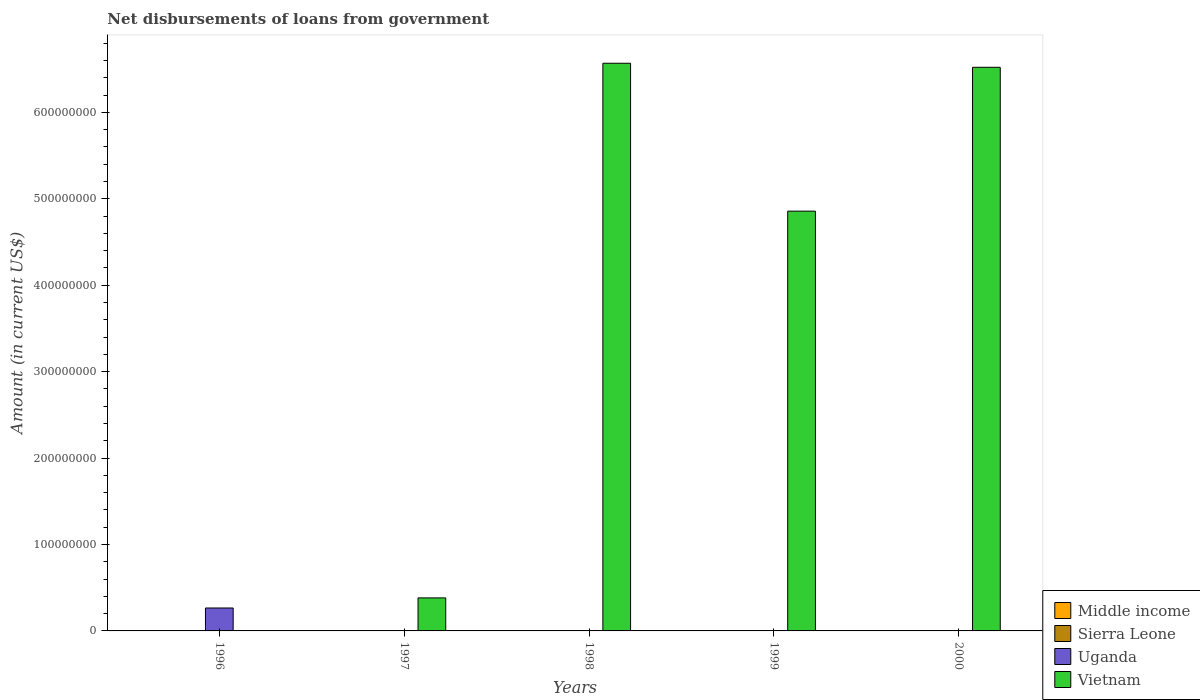How many bars are there on the 5th tick from the left?
Your answer should be compact. 2. How many bars are there on the 5th tick from the right?
Provide a succinct answer. 1. What is the label of the 4th group of bars from the left?
Ensure brevity in your answer.  1999. In how many cases, is the number of bars for a given year not equal to the number of legend labels?
Offer a terse response. 5. Across all years, what is the maximum amount of loan disbursed from government in Uganda?
Your response must be concise. 2.65e+07. Across all years, what is the minimum amount of loan disbursed from government in Uganda?
Your answer should be compact. 0. What is the total amount of loan disbursed from government in Sierra Leone in the graph?
Your answer should be compact. 6.80e+04. What is the difference between the amount of loan disbursed from government in Vietnam in 1998 and that in 2000?
Your answer should be very brief. 4.68e+06. What is the average amount of loan disbursed from government in Sierra Leone per year?
Your answer should be compact. 1.36e+04. What is the difference between the highest and the second highest amount of loan disbursed from government in Vietnam?
Provide a succinct answer. 4.68e+06. What is the difference between the highest and the lowest amount of loan disbursed from government in Uganda?
Your response must be concise. 2.65e+07. Is it the case that in every year, the sum of the amount of loan disbursed from government in Vietnam and amount of loan disbursed from government in Sierra Leone is greater than the sum of amount of loan disbursed from government in Uganda and amount of loan disbursed from government in Middle income?
Make the answer very short. No. Does the graph contain any zero values?
Provide a succinct answer. Yes. Does the graph contain grids?
Offer a terse response. No. What is the title of the graph?
Your answer should be compact. Net disbursements of loans from government. Does "Middle income" appear as one of the legend labels in the graph?
Give a very brief answer. Yes. What is the Amount (in current US$) in Middle income in 1996?
Make the answer very short. 0. What is the Amount (in current US$) in Sierra Leone in 1996?
Make the answer very short. 0. What is the Amount (in current US$) of Uganda in 1996?
Provide a succinct answer. 2.65e+07. What is the Amount (in current US$) in Vietnam in 1996?
Provide a succinct answer. 0. What is the Amount (in current US$) in Middle income in 1997?
Your answer should be compact. 0. What is the Amount (in current US$) of Sierra Leone in 1997?
Keep it short and to the point. 0. What is the Amount (in current US$) in Uganda in 1997?
Give a very brief answer. 0. What is the Amount (in current US$) of Vietnam in 1997?
Offer a very short reply. 3.82e+07. What is the Amount (in current US$) in Uganda in 1998?
Offer a very short reply. 0. What is the Amount (in current US$) of Vietnam in 1998?
Provide a succinct answer. 6.57e+08. What is the Amount (in current US$) of Vietnam in 1999?
Offer a terse response. 4.86e+08. What is the Amount (in current US$) in Sierra Leone in 2000?
Ensure brevity in your answer.  6.80e+04. What is the Amount (in current US$) of Uganda in 2000?
Offer a terse response. 0. What is the Amount (in current US$) in Vietnam in 2000?
Provide a short and direct response. 6.52e+08. Across all years, what is the maximum Amount (in current US$) in Sierra Leone?
Ensure brevity in your answer.  6.80e+04. Across all years, what is the maximum Amount (in current US$) in Uganda?
Offer a very short reply. 2.65e+07. Across all years, what is the maximum Amount (in current US$) in Vietnam?
Your answer should be very brief. 6.57e+08. Across all years, what is the minimum Amount (in current US$) of Uganda?
Your answer should be compact. 0. What is the total Amount (in current US$) in Middle income in the graph?
Provide a short and direct response. 0. What is the total Amount (in current US$) in Sierra Leone in the graph?
Provide a short and direct response. 6.80e+04. What is the total Amount (in current US$) of Uganda in the graph?
Make the answer very short. 2.65e+07. What is the total Amount (in current US$) in Vietnam in the graph?
Your response must be concise. 1.83e+09. What is the difference between the Amount (in current US$) of Vietnam in 1997 and that in 1998?
Keep it short and to the point. -6.19e+08. What is the difference between the Amount (in current US$) in Vietnam in 1997 and that in 1999?
Ensure brevity in your answer.  -4.48e+08. What is the difference between the Amount (in current US$) of Vietnam in 1997 and that in 2000?
Provide a short and direct response. -6.14e+08. What is the difference between the Amount (in current US$) of Vietnam in 1998 and that in 1999?
Offer a very short reply. 1.71e+08. What is the difference between the Amount (in current US$) in Vietnam in 1998 and that in 2000?
Ensure brevity in your answer.  4.68e+06. What is the difference between the Amount (in current US$) of Vietnam in 1999 and that in 2000?
Offer a terse response. -1.66e+08. What is the difference between the Amount (in current US$) in Uganda in 1996 and the Amount (in current US$) in Vietnam in 1997?
Your response must be concise. -1.17e+07. What is the difference between the Amount (in current US$) of Uganda in 1996 and the Amount (in current US$) of Vietnam in 1998?
Give a very brief answer. -6.30e+08. What is the difference between the Amount (in current US$) of Uganda in 1996 and the Amount (in current US$) of Vietnam in 1999?
Your answer should be very brief. -4.59e+08. What is the difference between the Amount (in current US$) of Uganda in 1996 and the Amount (in current US$) of Vietnam in 2000?
Keep it short and to the point. -6.26e+08. What is the average Amount (in current US$) of Sierra Leone per year?
Make the answer very short. 1.36e+04. What is the average Amount (in current US$) of Uganda per year?
Provide a succinct answer. 5.31e+06. What is the average Amount (in current US$) of Vietnam per year?
Provide a short and direct response. 3.67e+08. In the year 2000, what is the difference between the Amount (in current US$) in Sierra Leone and Amount (in current US$) in Vietnam?
Provide a succinct answer. -6.52e+08. What is the ratio of the Amount (in current US$) in Vietnam in 1997 to that in 1998?
Offer a terse response. 0.06. What is the ratio of the Amount (in current US$) of Vietnam in 1997 to that in 1999?
Give a very brief answer. 0.08. What is the ratio of the Amount (in current US$) of Vietnam in 1997 to that in 2000?
Offer a terse response. 0.06. What is the ratio of the Amount (in current US$) in Vietnam in 1998 to that in 1999?
Provide a short and direct response. 1.35. What is the ratio of the Amount (in current US$) of Vietnam in 1999 to that in 2000?
Give a very brief answer. 0.74. What is the difference between the highest and the second highest Amount (in current US$) in Vietnam?
Make the answer very short. 4.68e+06. What is the difference between the highest and the lowest Amount (in current US$) in Sierra Leone?
Offer a very short reply. 6.80e+04. What is the difference between the highest and the lowest Amount (in current US$) in Uganda?
Your response must be concise. 2.65e+07. What is the difference between the highest and the lowest Amount (in current US$) of Vietnam?
Your response must be concise. 6.57e+08. 